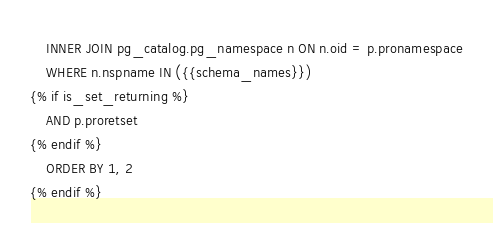<code> <loc_0><loc_0><loc_500><loc_500><_SQL_>    INNER JOIN pg_catalog.pg_namespace n ON n.oid = p.pronamespace
    WHERE n.nspname IN ({{schema_names}})
{% if is_set_returning %}
    AND p.proretset
{% endif %}
    ORDER BY 1, 2
{% endif %}</code> 